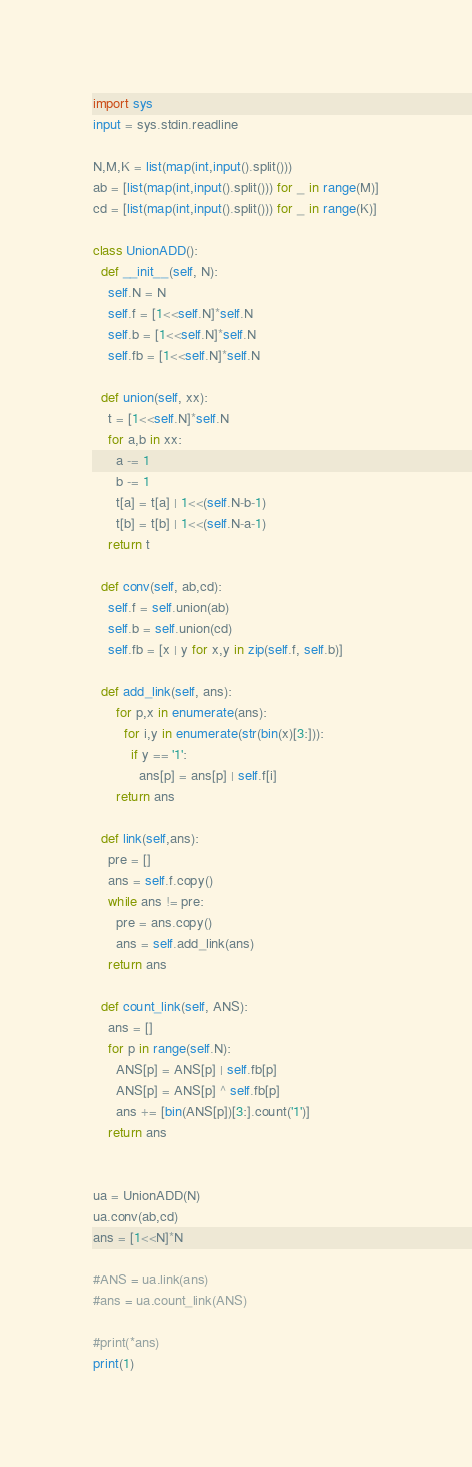<code> <loc_0><loc_0><loc_500><loc_500><_Python_>import sys
input = sys.stdin.readline
 
N,M,K = list(map(int,input().split()))
ab = [list(map(int,input().split())) for _ in range(M)]
cd = [list(map(int,input().split())) for _ in range(K)]

class UnionADD():
  def __init__(self, N):
    self.N = N
    self.f = [1<<self.N]*self.N
    self.b = [1<<self.N]*self.N
    self.fb = [1<<self.N]*self.N
  
  def union(self, xx):
    t = [1<<self.N]*self.N
    for a,b in xx:
      a -= 1
      b -= 1
      t[a] = t[a] | 1<<(self.N-b-1)
      t[b] = t[b] | 1<<(self.N-a-1)
    return t
  
  def conv(self, ab,cd):
    self.f = self.union(ab)
    self.b = self.union(cd)
    self.fb = [x | y for x,y in zip(self.f, self.b)]
  
  def add_link(self, ans):
      for p,x in enumerate(ans):
        for i,y in enumerate(str(bin(x)[3:])):
          if y == '1':
            ans[p] = ans[p] | self.f[i]
      return ans
  
  def link(self,ans):
    pre = []
    ans = self.f.copy()
    while ans != pre:
      pre = ans.copy()
      ans = self.add_link(ans)
    return ans
  
  def count_link(self, ANS):
    ans = []
    for p in range(self.N):
      ANS[p] = ANS[p] | self.fb[p]
      ANS[p] = ANS[p] ^ self.fb[p]
      ans += [bin(ANS[p])[3:].count('1')]
    return ans
    

ua = UnionADD(N)
ua.conv(ab,cd)
ans = [1<<N]*N

#ANS = ua.link(ans)
#ans = ua.count_link(ANS)

#print(*ans)
print(1)
</code> 